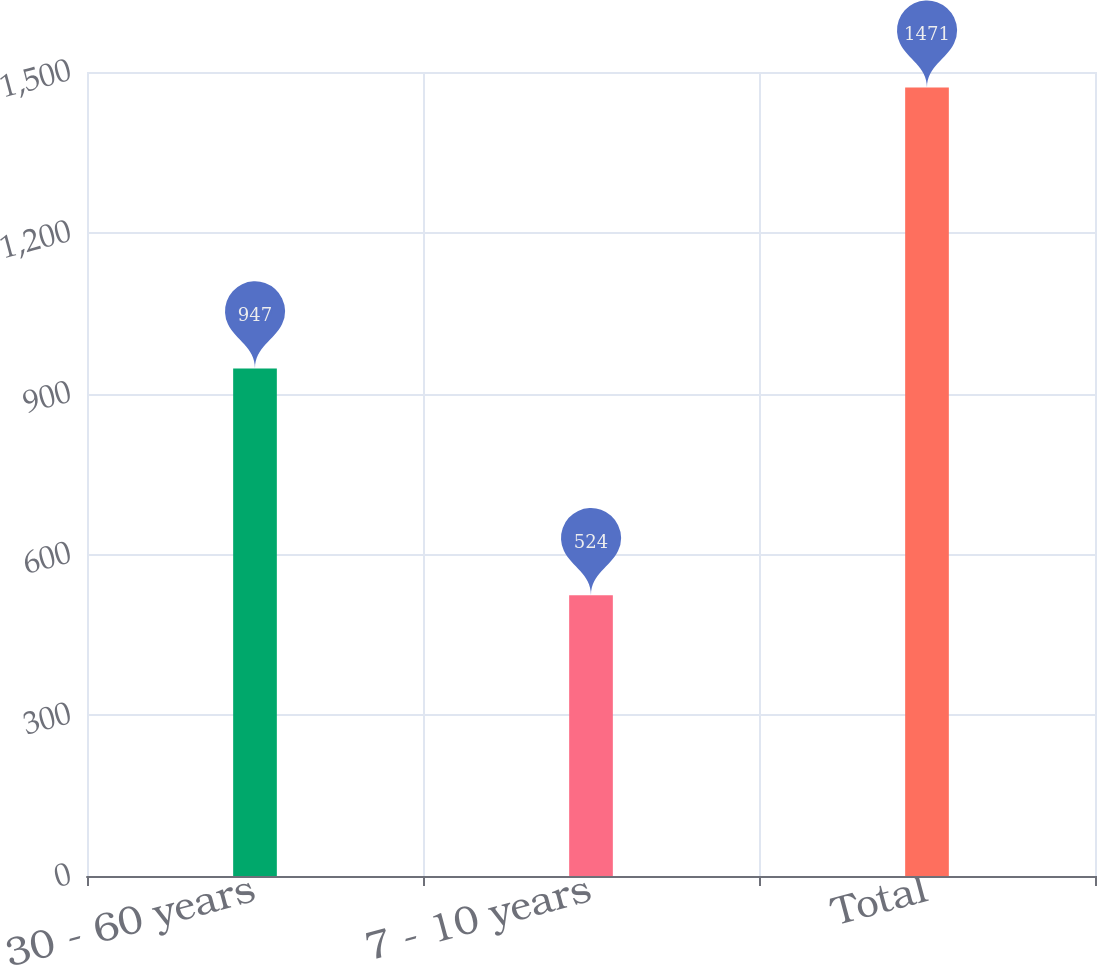<chart> <loc_0><loc_0><loc_500><loc_500><bar_chart><fcel>30 - 60 years<fcel>7 - 10 years<fcel>Total<nl><fcel>947<fcel>524<fcel>1471<nl></chart> 